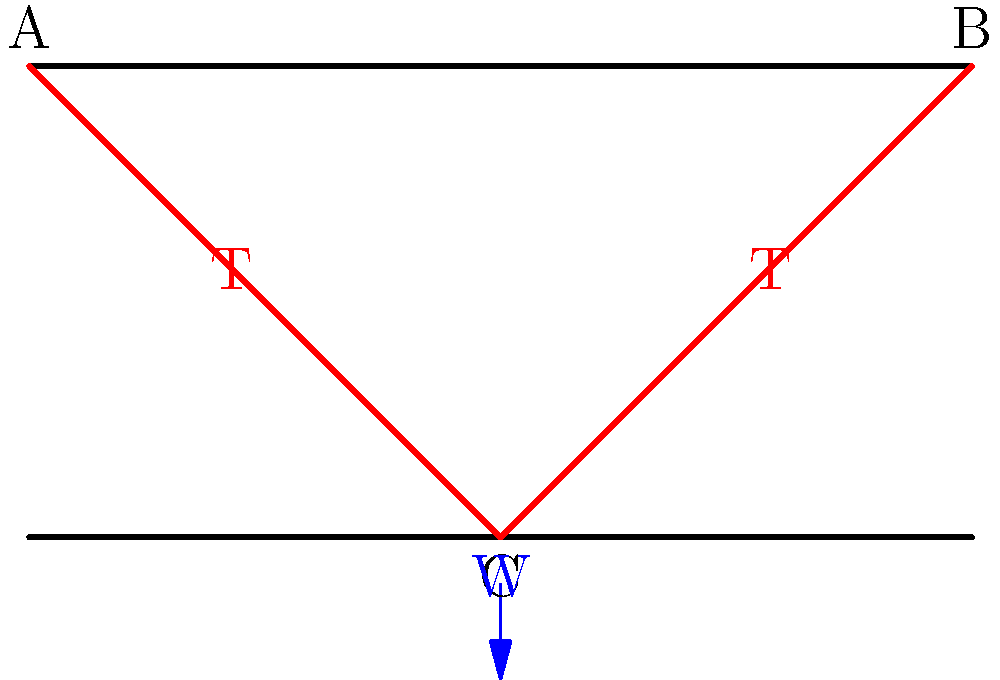In an early 20th-century suspension bridge design from Arkansas, two cables support a central load of 10,000 lbs at point C. The cables are attached to towers at points A and B, which are 100 feet apart and 50 feet high. Assuming the cables are straight and the load is applied at the midpoint, calculate the tension (T) in each cable. To solve this problem, we'll use the following steps:

1) First, we need to identify the triangle formed by the cable, tower, and half of the bridge span. This is a right triangle.

2) In this triangle:
   - The base is half the bridge span: 50 feet
   - The height is the tower height: 50 feet
   - The hypotenuse is the cable

3) We can find the angle the cable makes with the horizontal using the tangent function:
   $\tan \theta = \frac{opposite}{adjacent} = \frac{50}{50} = 1$
   $\theta = \arctan(1) = 45°$

4) Now, we can set up a force diagram. The tension in the cable (T) has two components:
   - Vertical component: $T_v = T \sin 45°$
   - Horizontal component: $T_h = T \cos 45°$

5) The vertical component of the tension must balance half the weight (since there are two cables):
   $T_v = T \sin 45° = 5000 \text{ lbs}$

6) We can solve for T:
   $T = \frac{5000}{\sin 45°} = \frac{5000}{\frac{\sqrt{2}}{2}} = 5000 \sqrt{2} \approx 7071 \text{ lbs}$

7) We can verify this by checking the horizontal component:
   $T_h = T \cos 45° = 7071 \cdot \frac{\sqrt{2}}{2} = 5000 \text{ lbs}$

This means the horizontal components of the two cables balance each other, as expected.
Answer: 7071 lbs 